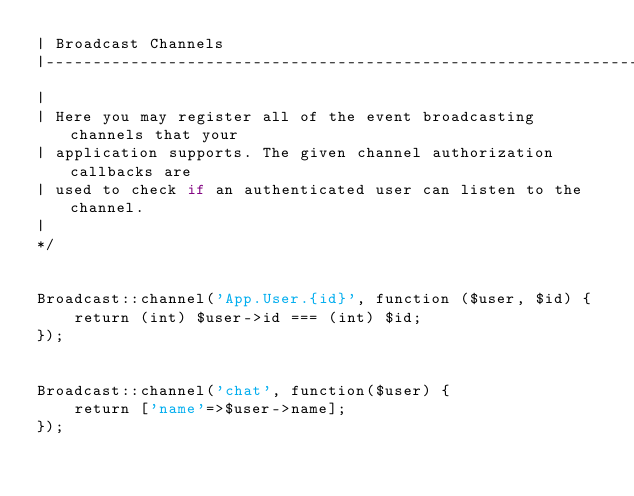Convert code to text. <code><loc_0><loc_0><loc_500><loc_500><_PHP_>| Broadcast Channels
|--------------------------------------------------------------------------
|
| Here you may register all of the event broadcasting channels that your
| application supports. The given channel authorization callbacks are
| used to check if an authenticated user can listen to the channel.
|
*/


Broadcast::channel('App.User.{id}', function ($user, $id) {
    return (int) $user->id === (int) $id;
});


Broadcast::channel('chat', function($user) {
    return ['name'=>$user->name];
});
</code> 